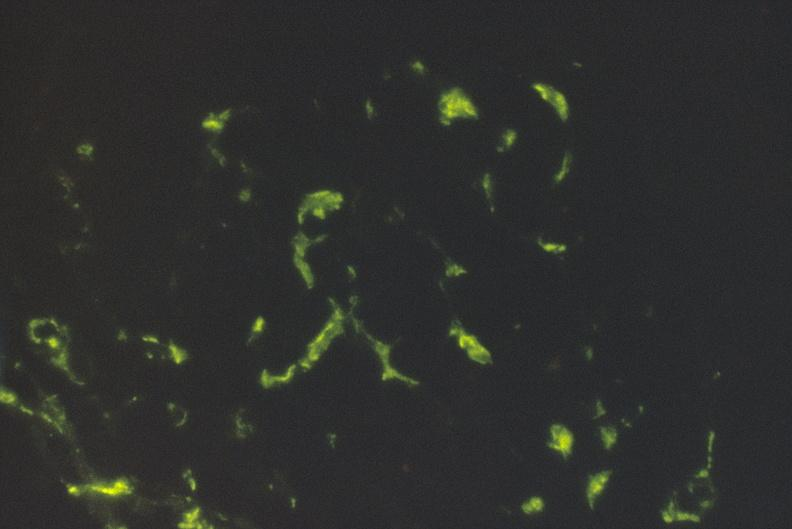where is this?
Answer the question using a single word or phrase. Urinary 